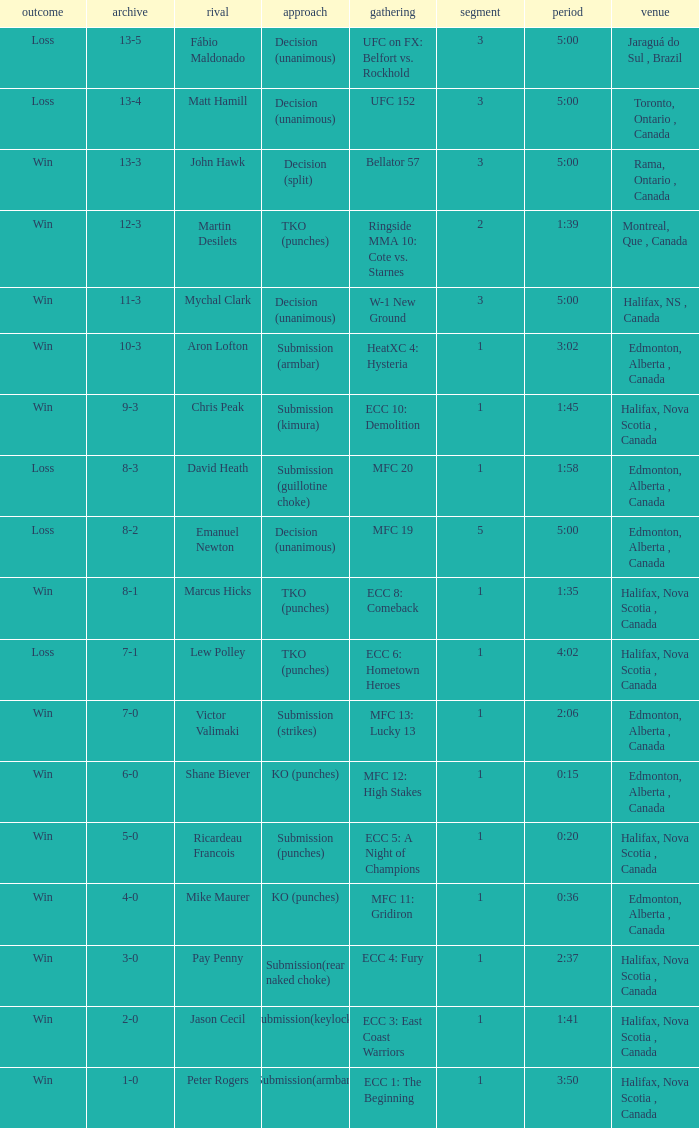Could you help me parse every detail presented in this table? {'header': ['outcome', 'archive', 'rival', 'approach', 'gathering', 'segment', 'period', 'venue'], 'rows': [['Loss', '13-5', 'Fábio Maldonado', 'Decision (unanimous)', 'UFC on FX: Belfort vs. Rockhold', '3', '5:00', 'Jaraguá do Sul , Brazil'], ['Loss', '13-4', 'Matt Hamill', 'Decision (unanimous)', 'UFC 152', '3', '5:00', 'Toronto, Ontario , Canada'], ['Win', '13-3', 'John Hawk', 'Decision (split)', 'Bellator 57', '3', '5:00', 'Rama, Ontario , Canada'], ['Win', '12-3', 'Martin Desilets', 'TKO (punches)', 'Ringside MMA 10: Cote vs. Starnes', '2', '1:39', 'Montreal, Que , Canada'], ['Win', '11-3', 'Mychal Clark', 'Decision (unanimous)', 'W-1 New Ground', '3', '5:00', 'Halifax, NS , Canada'], ['Win', '10-3', 'Aron Lofton', 'Submission (armbar)', 'HeatXC 4: Hysteria', '1', '3:02', 'Edmonton, Alberta , Canada'], ['Win', '9-3', 'Chris Peak', 'Submission (kimura)', 'ECC 10: Demolition', '1', '1:45', 'Halifax, Nova Scotia , Canada'], ['Loss', '8-3', 'David Heath', 'Submission (guillotine choke)', 'MFC 20', '1', '1:58', 'Edmonton, Alberta , Canada'], ['Loss', '8-2', 'Emanuel Newton', 'Decision (unanimous)', 'MFC 19', '5', '5:00', 'Edmonton, Alberta , Canada'], ['Win', '8-1', 'Marcus Hicks', 'TKO (punches)', 'ECC 8: Comeback', '1', '1:35', 'Halifax, Nova Scotia , Canada'], ['Loss', '7-1', 'Lew Polley', 'TKO (punches)', 'ECC 6: Hometown Heroes', '1', '4:02', 'Halifax, Nova Scotia , Canada'], ['Win', '7-0', 'Victor Valimaki', 'Submission (strikes)', 'MFC 13: Lucky 13', '1', '2:06', 'Edmonton, Alberta , Canada'], ['Win', '6-0', 'Shane Biever', 'KO (punches)', 'MFC 12: High Stakes', '1', '0:15', 'Edmonton, Alberta , Canada'], ['Win', '5-0', 'Ricardeau Francois', 'Submission (punches)', 'ECC 5: A Night of Champions', '1', '0:20', 'Halifax, Nova Scotia , Canada'], ['Win', '4-0', 'Mike Maurer', 'KO (punches)', 'MFC 11: Gridiron', '1', '0:36', 'Edmonton, Alberta , Canada'], ['Win', '3-0', 'Pay Penny', 'Submission(rear naked choke)', 'ECC 4: Fury', '1', '2:37', 'Halifax, Nova Scotia , Canada'], ['Win', '2-0', 'Jason Cecil', 'Submission(keylock)', 'ECC 3: East Coast Warriors', '1', '1:41', 'Halifax, Nova Scotia , Canada'], ['Win', '1-0', 'Peter Rogers', 'Submission(armbar)', 'ECC 1: The Beginning', '1', '3:50', 'Halifax, Nova Scotia , Canada']]} What is the method of the match with 1 round and a time of 1:58? Submission (guillotine choke). 